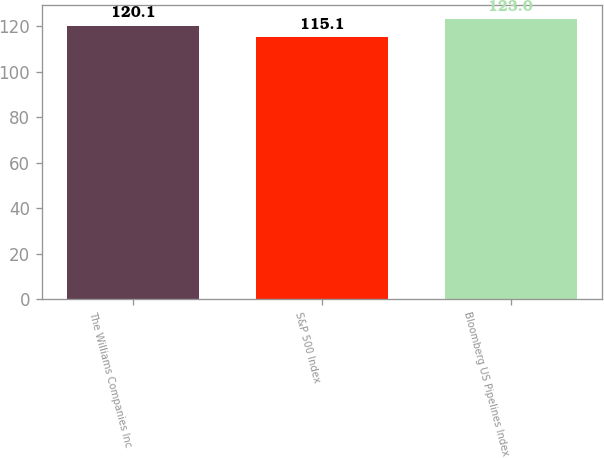Convert chart to OTSL. <chart><loc_0><loc_0><loc_500><loc_500><bar_chart><fcel>The Williams Companies Inc<fcel>S&P 500 Index<fcel>Bloomberg US Pipelines Index<nl><fcel>120.1<fcel>115.1<fcel>123<nl></chart> 